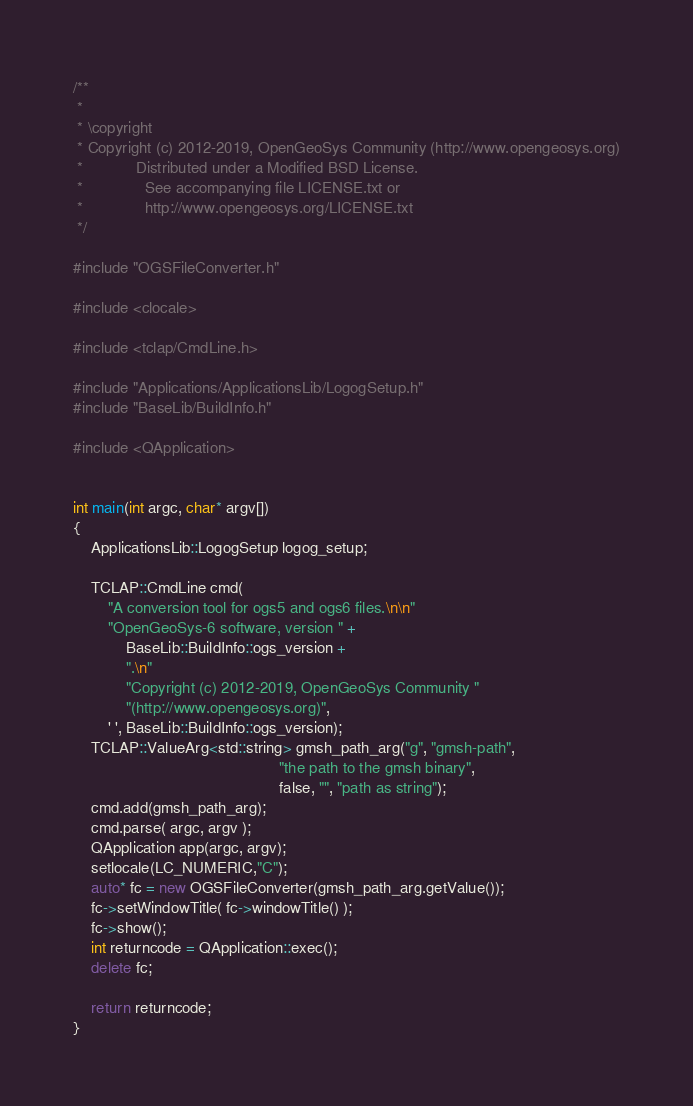Convert code to text. <code><loc_0><loc_0><loc_500><loc_500><_C++_>/**
 *
 * \copyright
 * Copyright (c) 2012-2019, OpenGeoSys Community (http://www.opengeosys.org)
 *            Distributed under a Modified BSD License.
 *              See accompanying file LICENSE.txt or
 *              http://www.opengeosys.org/LICENSE.txt
 */

#include "OGSFileConverter.h"

#include <clocale>

#include <tclap/CmdLine.h>

#include "Applications/ApplicationsLib/LogogSetup.h"
#include "BaseLib/BuildInfo.h"

#include <QApplication>


int main(int argc, char* argv[])
{
    ApplicationsLib::LogogSetup logog_setup;

    TCLAP::CmdLine cmd(
        "A conversion tool for ogs5 and ogs6 files.\n\n"
        "OpenGeoSys-6 software, version " +
            BaseLib::BuildInfo::ogs_version +
            ".\n"
            "Copyright (c) 2012-2019, OpenGeoSys Community "
            "(http://www.opengeosys.org)",
        ' ', BaseLib::BuildInfo::ogs_version);
    TCLAP::ValueArg<std::string> gmsh_path_arg("g", "gmsh-path",
                                               "the path to the gmsh binary",
                                               false, "", "path as string");
    cmd.add(gmsh_path_arg);
    cmd.parse( argc, argv );
    QApplication app(argc, argv);
    setlocale(LC_NUMERIC,"C");
    auto* fc = new OGSFileConverter(gmsh_path_arg.getValue());
    fc->setWindowTitle( fc->windowTitle() );
    fc->show();
    int returncode = QApplication::exec();
    delete fc;

    return returncode;
}
</code> 